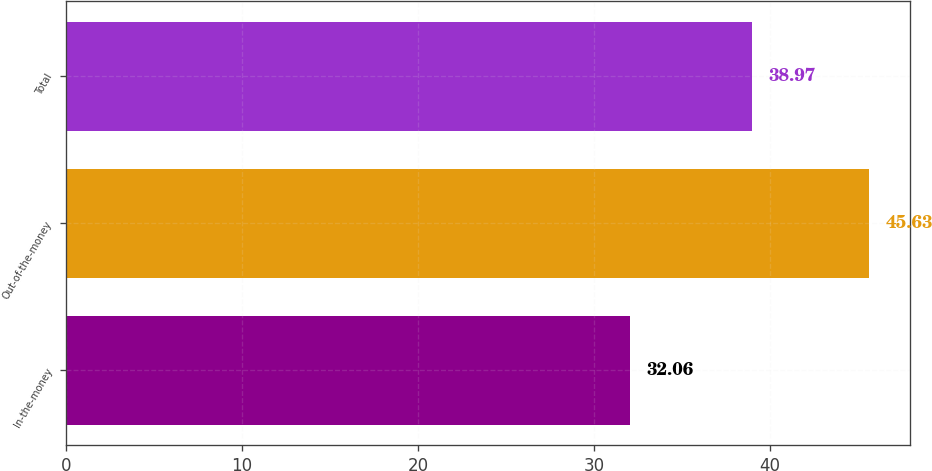Convert chart to OTSL. <chart><loc_0><loc_0><loc_500><loc_500><bar_chart><fcel>In-the-money<fcel>Out-of-the-money<fcel>Total<nl><fcel>32.06<fcel>45.63<fcel>38.97<nl></chart> 